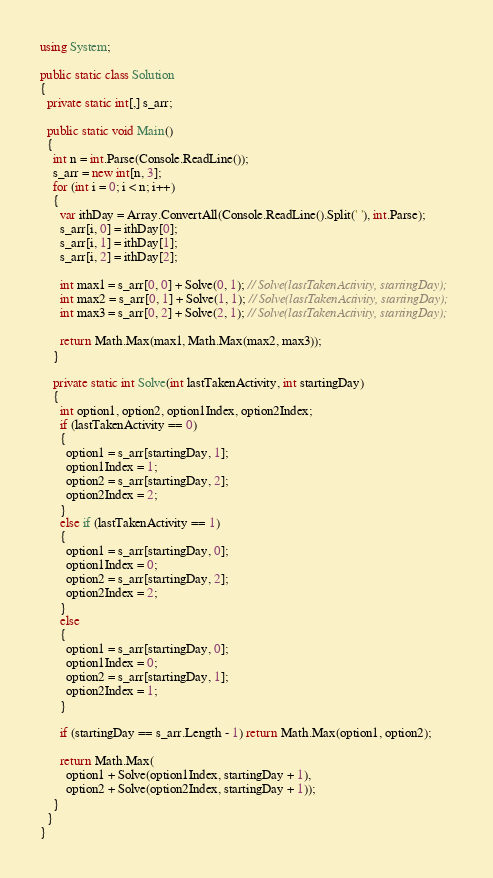Convert code to text. <code><loc_0><loc_0><loc_500><loc_500><_C#_>using System;

public static class Solution
{
  private static int[,] s_arr;

  public static void Main()
  {
    int n = int.Parse(Console.ReadLine());
    s_arr = new int[n, 3];
    for (int i = 0; i < n; i++)
    {
      var ithDay = Array.ConvertAll(Console.ReadLine().Split(' '), int.Parse);
      s_arr[i, 0] = ithDay[0];
      s_arr[i, 1] = ithDay[1];
      s_arr[i, 2] = ithDay[2];

      int max1 = s_arr[0, 0] + Solve(0, 1); // Solve(lastTakenActivity, startingDay);
      int max2 = s_arr[0, 1] + Solve(1, 1); // Solve(lastTakenActivity, startingDay);
      int max3 = s_arr[0, 2] + Solve(2, 1); // Solve(lastTakenActivity, startingDay);

      return Math.Max(max1, Math.Max(max2, max3));
    }

    private static int Solve(int lastTakenActivity, int startingDay)
    {
      int option1, option2, option1Index, option2Index;
      if (lastTakenActivity == 0)
      {
        option1 = s_arr[startingDay, 1];
        option1Index = 1;
        option2 = s_arr[startingDay, 2];
        option2Index = 2;
      }
      else if (lastTakenActivity == 1)
      {
        option1 = s_arr[startingDay, 0];
        option1Index = 0;
        option2 = s_arr[startingDay, 2];
        option2Index = 2;
      }
      else
      {
        option1 = s_arr[startingDay, 0];
        option1Index = 0;
        option2 = s_arr[startingDay, 1];
        option2Index = 1;
      }
      
      if (startingDay == s_arr.Length - 1) return Math.Max(option1, option2);

      return Math.Max(
        option1 + Solve(option1Index, startingDay + 1),
        option2 + Solve(option2Index, startingDay + 1));
    }
  }
}</code> 